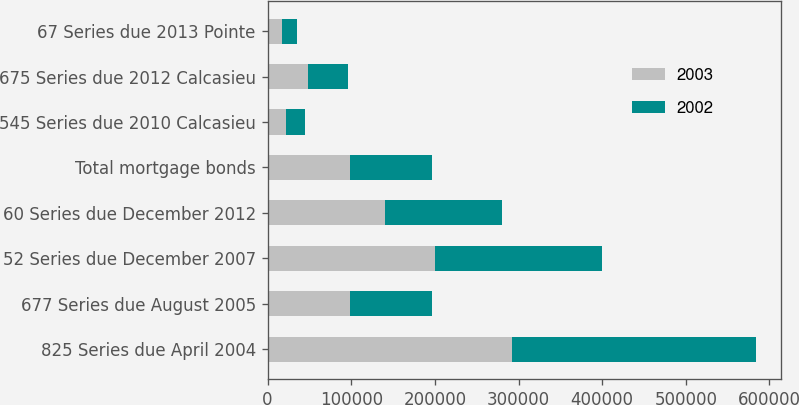Convert chart. <chart><loc_0><loc_0><loc_500><loc_500><stacked_bar_chart><ecel><fcel>825 Series due April 2004<fcel>677 Series due August 2005<fcel>52 Series due December 2007<fcel>60 Series due December 2012<fcel>Total mortgage bonds<fcel>545 Series due 2010 Calcasieu<fcel>675 Series due 2012 Calcasieu<fcel>67 Series due 2013 Pointe<nl><fcel>2003<fcel>292000<fcel>98000<fcel>200000<fcel>140000<fcel>98000<fcel>22095<fcel>48285<fcel>17450<nl><fcel>2002<fcel>292000<fcel>98000<fcel>200000<fcel>140000<fcel>98000<fcel>22095<fcel>48285<fcel>17450<nl></chart> 